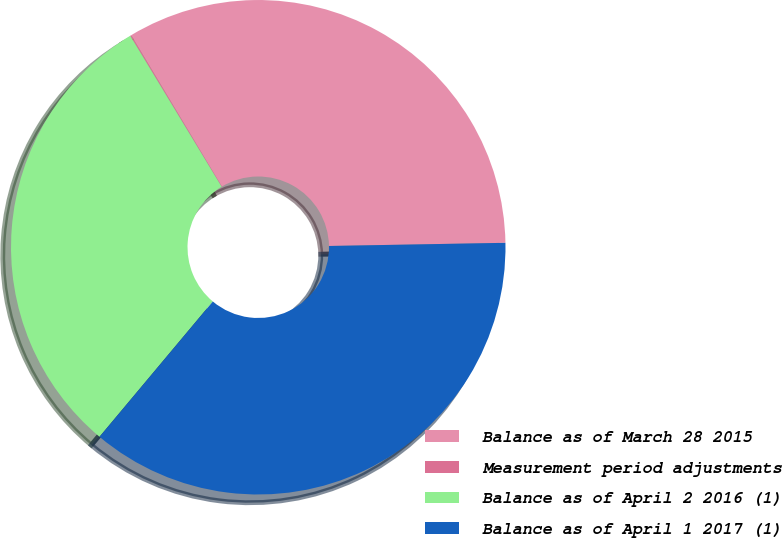Convert chart to OTSL. <chart><loc_0><loc_0><loc_500><loc_500><pie_chart><fcel>Balance as of March 28 2015<fcel>Measurement period adjustments<fcel>Balance as of April 2 2016 (1)<fcel>Balance as of April 1 2017 (1)<nl><fcel>33.31%<fcel>0.07%<fcel>30.24%<fcel>36.38%<nl></chart> 